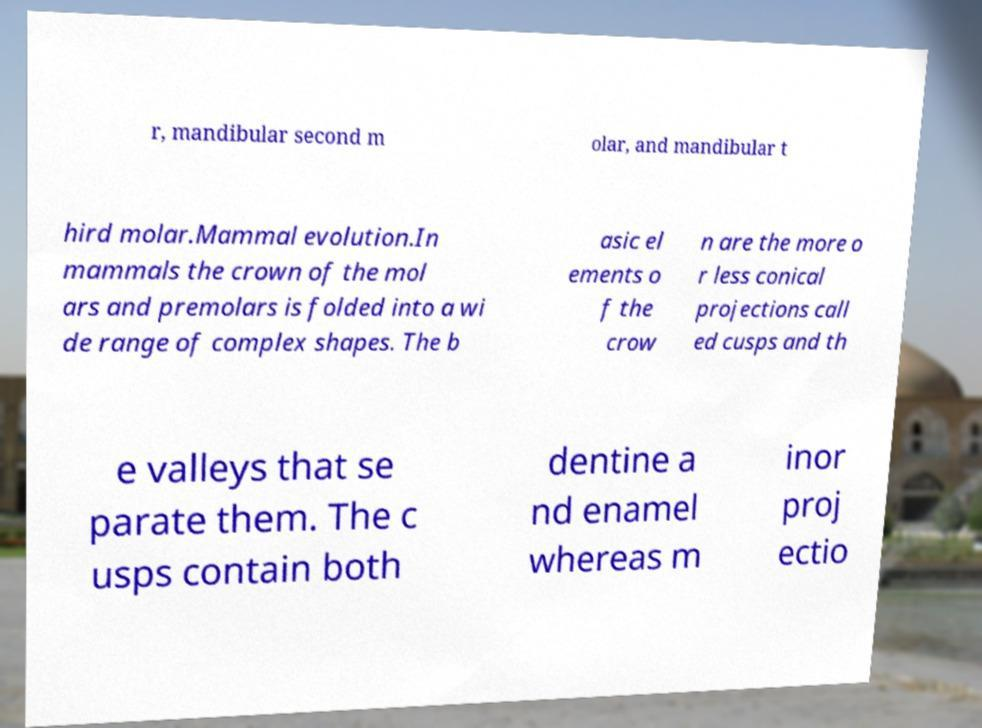Could you extract and type out the text from this image? r, mandibular second m olar, and mandibular t hird molar.Mammal evolution.In mammals the crown of the mol ars and premolars is folded into a wi de range of complex shapes. The b asic el ements o f the crow n are the more o r less conical projections call ed cusps and th e valleys that se parate them. The c usps contain both dentine a nd enamel whereas m inor proj ectio 